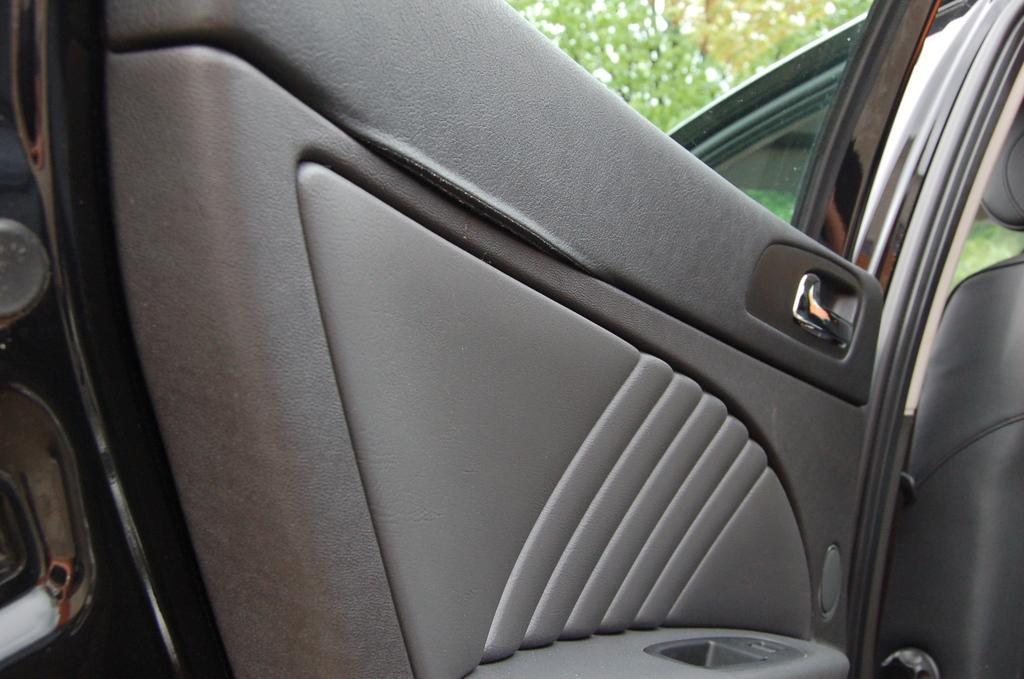Could you give a brief overview of what you see in this image? This image is taken outside the car in which there is a car in the center and their are trees. 